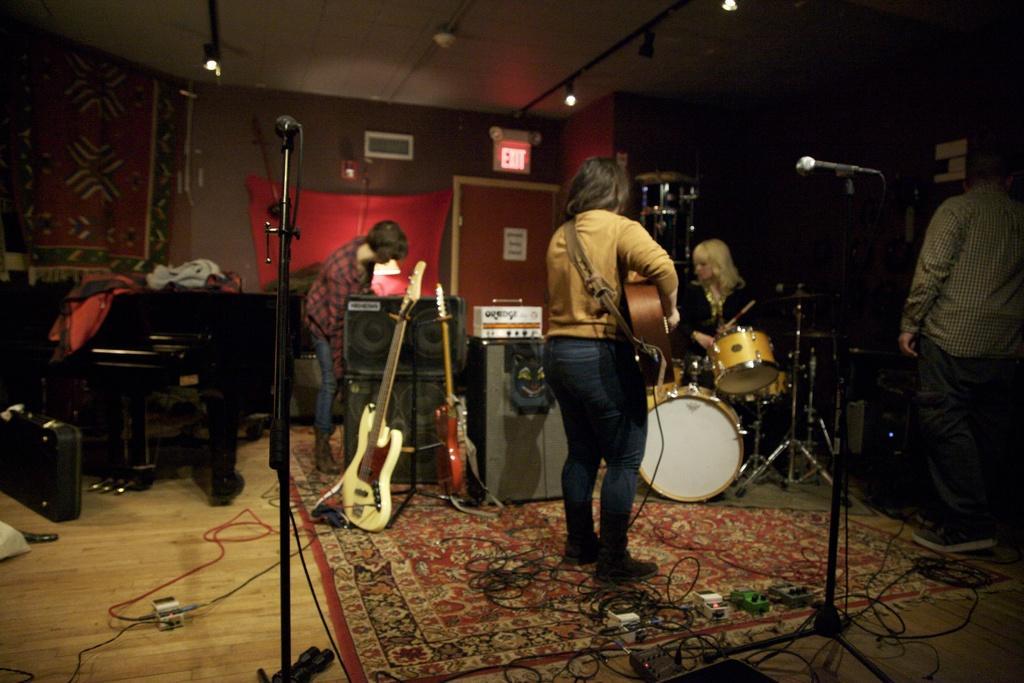Could you give a brief overview of what you see in this image? In the image we can see there are people who are standing and holding guitar in their hand and there is a woman who is playing drums and there is a man standing here and there is a man standing in front of speakers. 